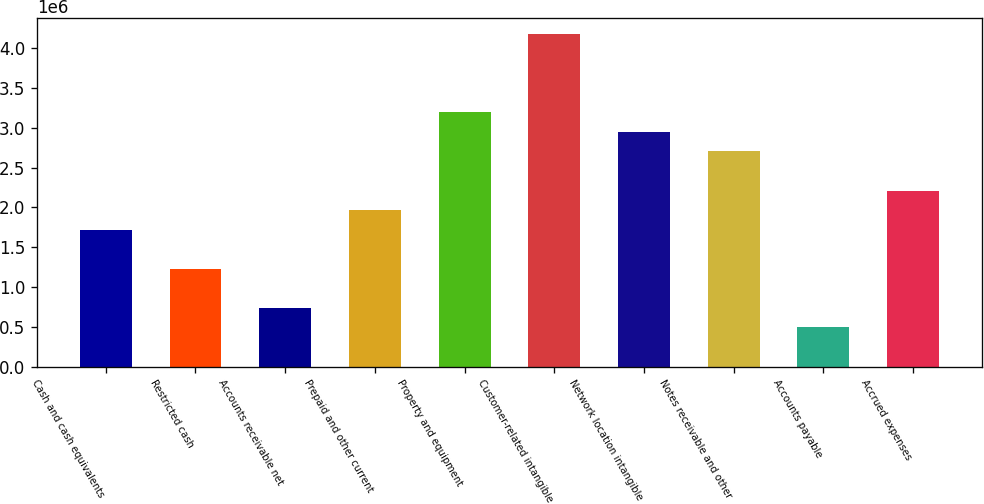Convert chart to OTSL. <chart><loc_0><loc_0><loc_500><loc_500><bar_chart><fcel>Cash and cash equivalents<fcel>Restricted cash<fcel>Accounts receivable net<fcel>Prepaid and other current<fcel>Property and equipment<fcel>Customer-related intangible<fcel>Network location intangible<fcel>Notes receivable and other<fcel>Accounts payable<fcel>Accrued expenses<nl><fcel>1.72045e+06<fcel>1.2297e+06<fcel>738949<fcel>1.96583e+06<fcel>3.19271e+06<fcel>4.17422e+06<fcel>2.94733e+06<fcel>2.70196e+06<fcel>493572<fcel>2.21121e+06<nl></chart> 